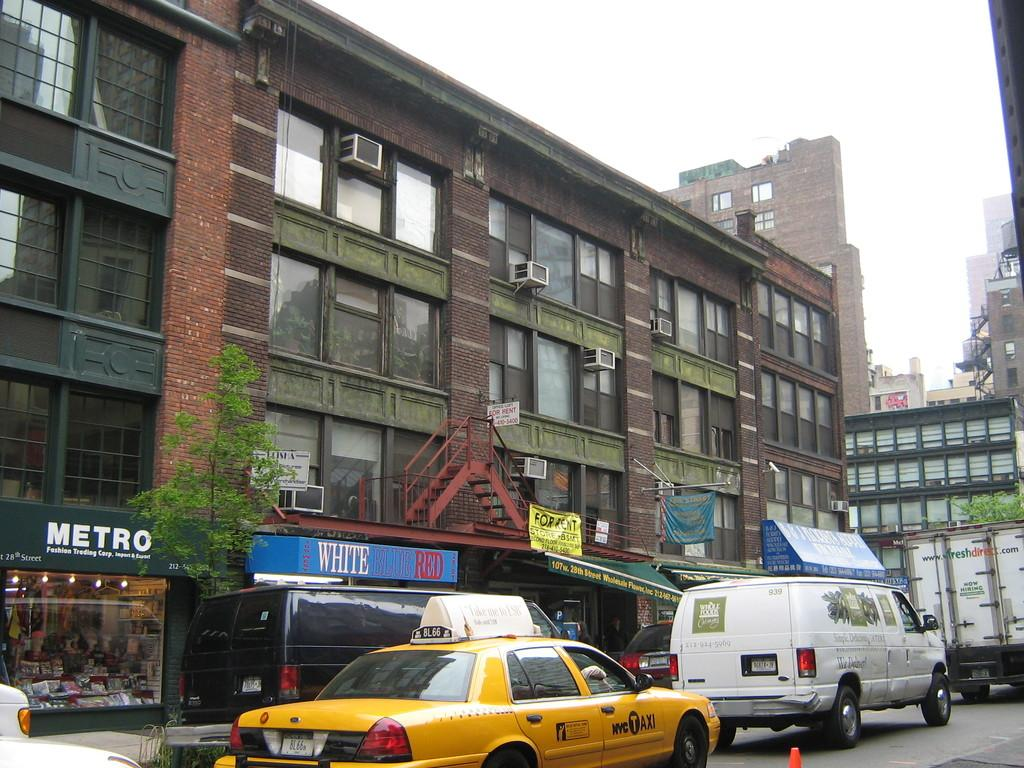<image>
Relay a brief, clear account of the picture shown. A sign for White Blue Red lies under a red fire escape. 